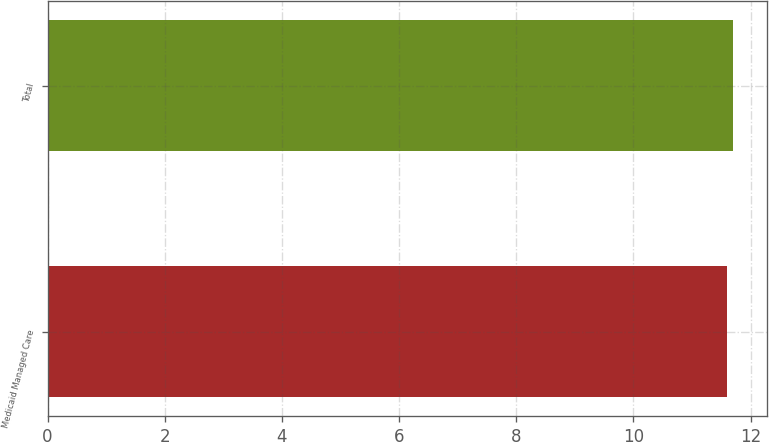<chart> <loc_0><loc_0><loc_500><loc_500><bar_chart><fcel>Medicaid Managed Care<fcel>Total<nl><fcel>11.6<fcel>11.7<nl></chart> 